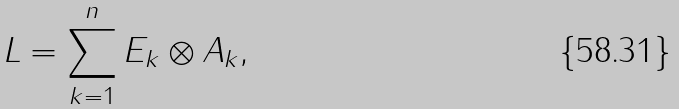<formula> <loc_0><loc_0><loc_500><loc_500>L = \sum _ { k = 1 } ^ { n } E _ { k } \otimes A _ { k } ,</formula> 